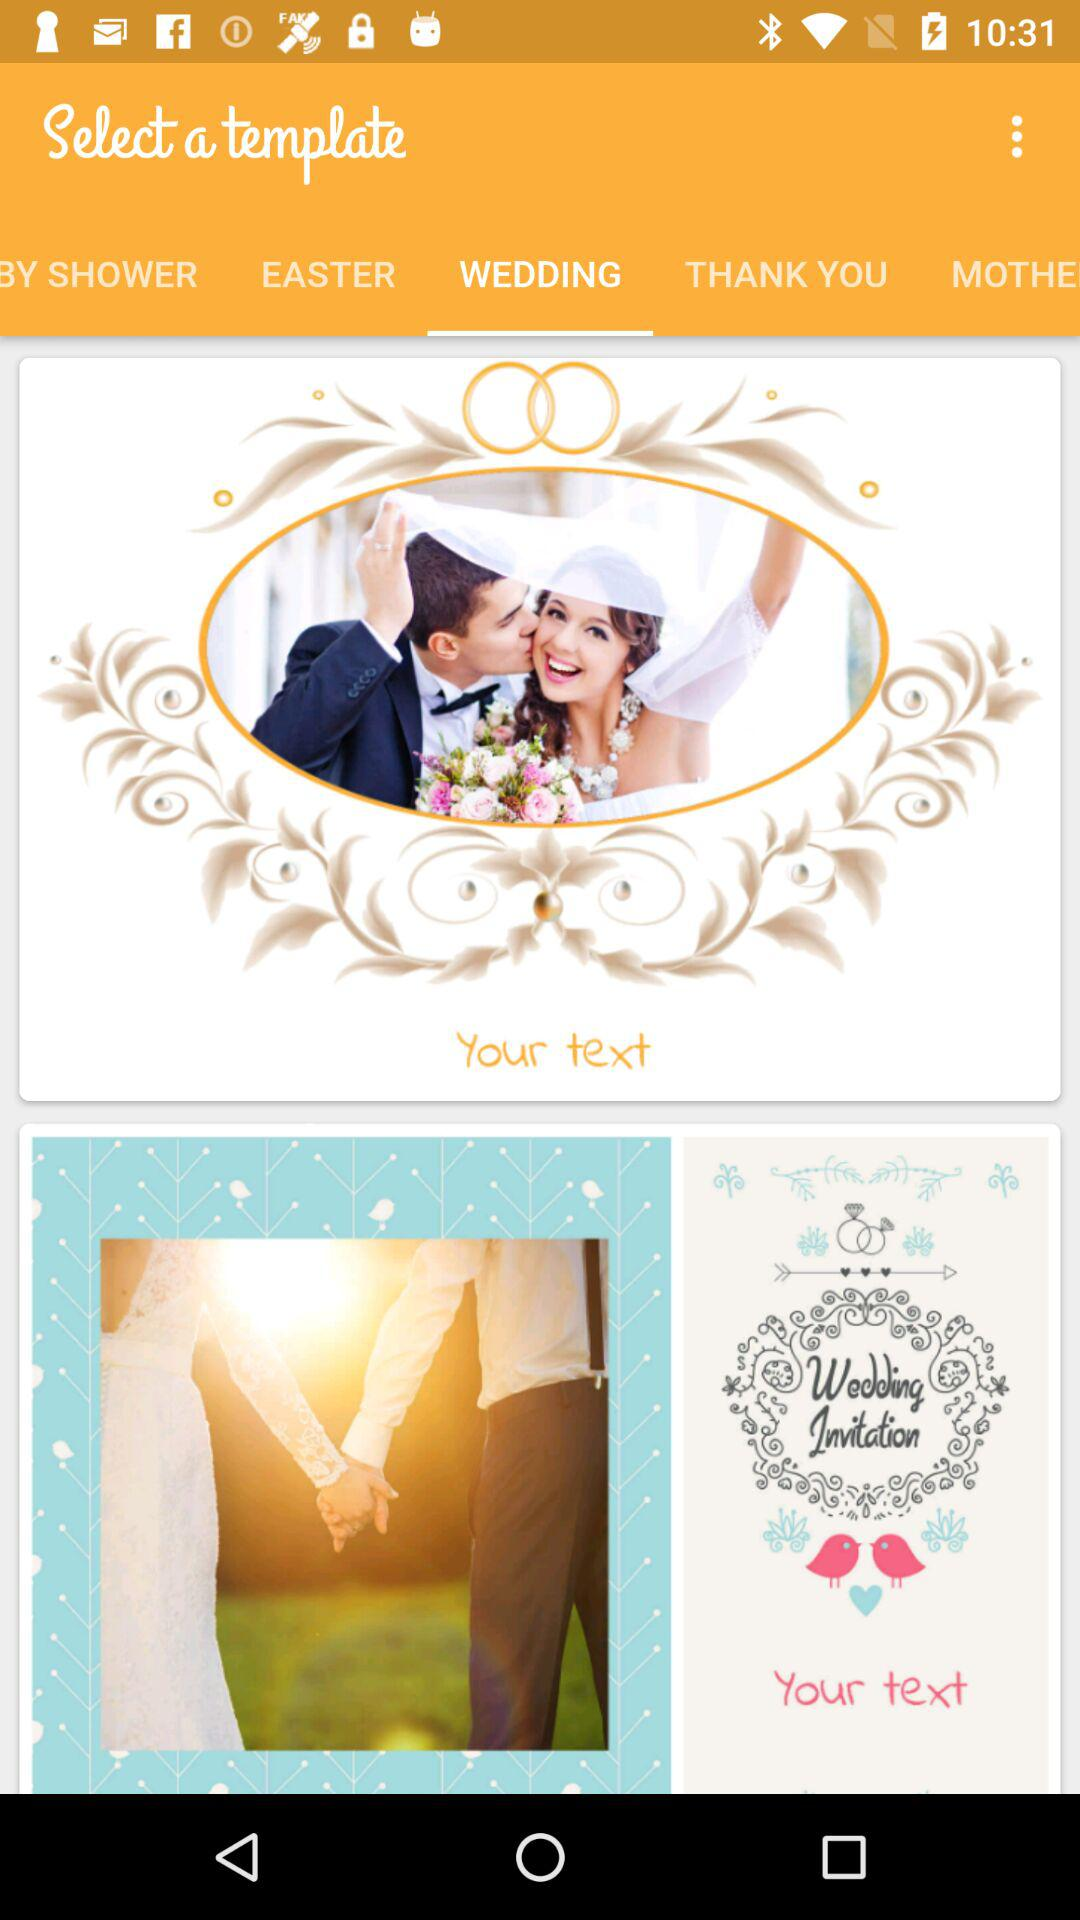What's the application name?
When the provided information is insufficient, respond with <no answer>. <no answer> 